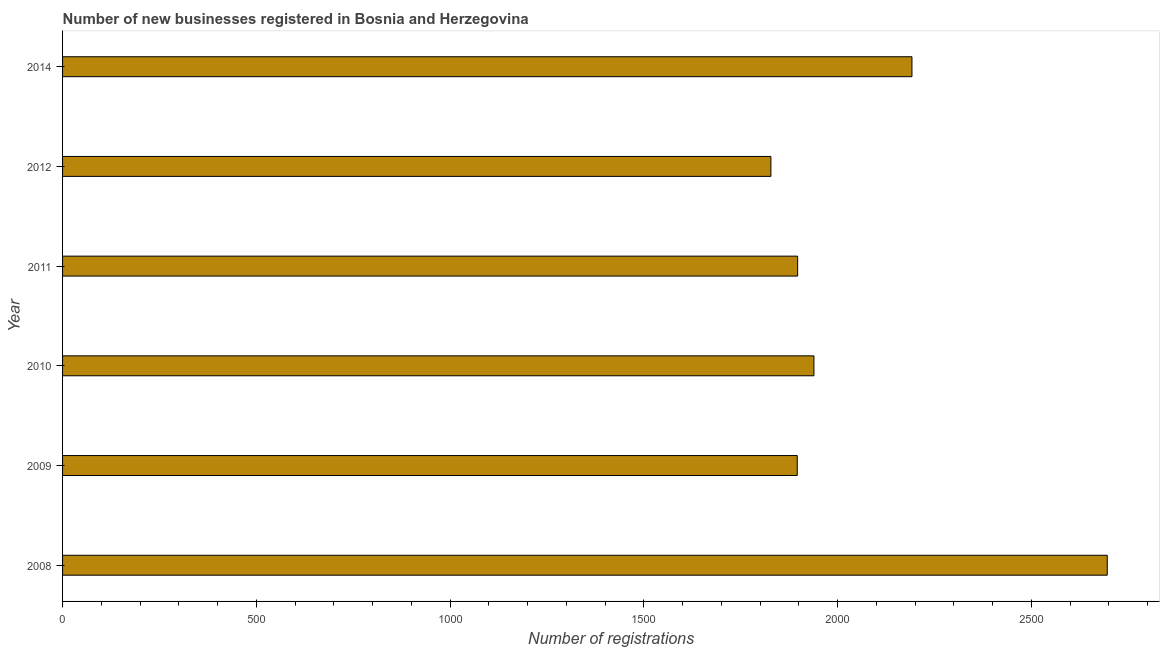Does the graph contain any zero values?
Your response must be concise. No. What is the title of the graph?
Offer a terse response. Number of new businesses registered in Bosnia and Herzegovina. What is the label or title of the X-axis?
Offer a terse response. Number of registrations. What is the number of new business registrations in 2011?
Your answer should be compact. 1897. Across all years, what is the maximum number of new business registrations?
Your response must be concise. 2696. Across all years, what is the minimum number of new business registrations?
Keep it short and to the point. 1828. What is the sum of the number of new business registrations?
Provide a short and direct response. 1.24e+04. What is the difference between the number of new business registrations in 2011 and 2014?
Your answer should be compact. -295. What is the average number of new business registrations per year?
Give a very brief answer. 2074. What is the median number of new business registrations?
Your response must be concise. 1918. What is the ratio of the number of new business registrations in 2008 to that in 2011?
Provide a succinct answer. 1.42. Is the number of new business registrations in 2009 less than that in 2011?
Offer a terse response. Yes. Is the difference between the number of new business registrations in 2010 and 2011 greater than the difference between any two years?
Your answer should be very brief. No. What is the difference between the highest and the second highest number of new business registrations?
Your response must be concise. 504. What is the difference between the highest and the lowest number of new business registrations?
Make the answer very short. 868. In how many years, is the number of new business registrations greater than the average number of new business registrations taken over all years?
Ensure brevity in your answer.  2. How many years are there in the graph?
Keep it short and to the point. 6. What is the Number of registrations in 2008?
Make the answer very short. 2696. What is the Number of registrations in 2009?
Provide a succinct answer. 1896. What is the Number of registrations of 2010?
Offer a very short reply. 1939. What is the Number of registrations in 2011?
Give a very brief answer. 1897. What is the Number of registrations in 2012?
Your response must be concise. 1828. What is the Number of registrations in 2014?
Keep it short and to the point. 2192. What is the difference between the Number of registrations in 2008 and 2009?
Your answer should be very brief. 800. What is the difference between the Number of registrations in 2008 and 2010?
Provide a succinct answer. 757. What is the difference between the Number of registrations in 2008 and 2011?
Your answer should be very brief. 799. What is the difference between the Number of registrations in 2008 and 2012?
Make the answer very short. 868. What is the difference between the Number of registrations in 2008 and 2014?
Offer a very short reply. 504. What is the difference between the Number of registrations in 2009 and 2010?
Ensure brevity in your answer.  -43. What is the difference between the Number of registrations in 2009 and 2012?
Your answer should be compact. 68. What is the difference between the Number of registrations in 2009 and 2014?
Make the answer very short. -296. What is the difference between the Number of registrations in 2010 and 2012?
Provide a short and direct response. 111. What is the difference between the Number of registrations in 2010 and 2014?
Keep it short and to the point. -253. What is the difference between the Number of registrations in 2011 and 2012?
Offer a very short reply. 69. What is the difference between the Number of registrations in 2011 and 2014?
Give a very brief answer. -295. What is the difference between the Number of registrations in 2012 and 2014?
Your response must be concise. -364. What is the ratio of the Number of registrations in 2008 to that in 2009?
Your answer should be compact. 1.42. What is the ratio of the Number of registrations in 2008 to that in 2010?
Offer a terse response. 1.39. What is the ratio of the Number of registrations in 2008 to that in 2011?
Keep it short and to the point. 1.42. What is the ratio of the Number of registrations in 2008 to that in 2012?
Provide a succinct answer. 1.48. What is the ratio of the Number of registrations in 2008 to that in 2014?
Your answer should be compact. 1.23. What is the ratio of the Number of registrations in 2009 to that in 2011?
Offer a very short reply. 1. What is the ratio of the Number of registrations in 2009 to that in 2012?
Your answer should be very brief. 1.04. What is the ratio of the Number of registrations in 2009 to that in 2014?
Your answer should be compact. 0.86. What is the ratio of the Number of registrations in 2010 to that in 2011?
Make the answer very short. 1.02. What is the ratio of the Number of registrations in 2010 to that in 2012?
Ensure brevity in your answer.  1.06. What is the ratio of the Number of registrations in 2010 to that in 2014?
Your answer should be compact. 0.89. What is the ratio of the Number of registrations in 2011 to that in 2012?
Keep it short and to the point. 1.04. What is the ratio of the Number of registrations in 2011 to that in 2014?
Make the answer very short. 0.86. What is the ratio of the Number of registrations in 2012 to that in 2014?
Your response must be concise. 0.83. 